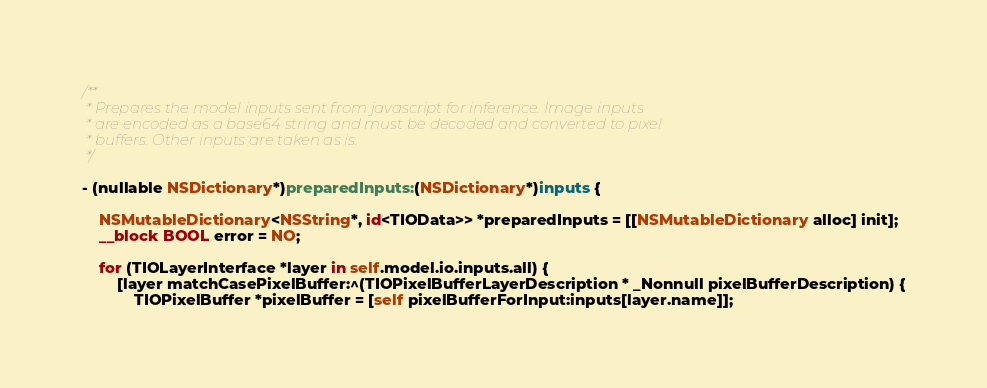<code> <loc_0><loc_0><loc_500><loc_500><_ObjectiveC_>/**
 * Prepares the model inputs sent from javascript for inference. Image inputs
 * are encoded as a base64 string and must be decoded and converted to pixel
 * buffers. Other inputs are taken as is.
 */

- (nullable NSDictionary*)preparedInputs:(NSDictionary*)inputs {
    
    NSMutableDictionary<NSString*, id<TIOData>> *preparedInputs = [[NSMutableDictionary alloc] init];
    __block BOOL error = NO;
    
    for (TIOLayerInterface *layer in self.model.io.inputs.all) {
        [layer matchCasePixelBuffer:^(TIOPixelBufferLayerDescription * _Nonnull pixelBufferDescription) {
            TIOPixelBuffer *pixelBuffer = [self pixelBufferForInput:inputs[layer.name]];</code> 